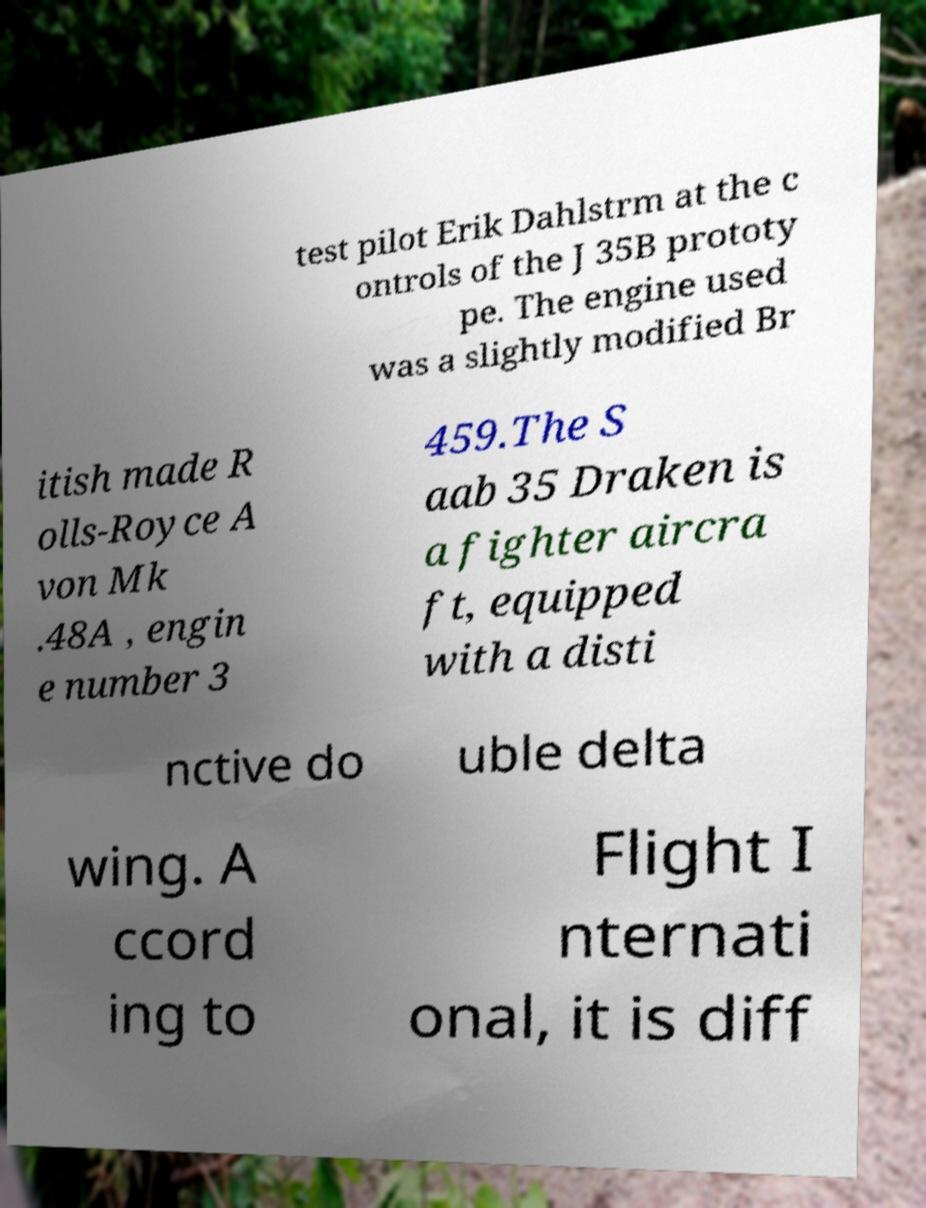There's text embedded in this image that I need extracted. Can you transcribe it verbatim? test pilot Erik Dahlstrm at the c ontrols of the J 35B prototy pe. The engine used was a slightly modified Br itish made R olls-Royce A von Mk .48A , engin e number 3 459.The S aab 35 Draken is a fighter aircra ft, equipped with a disti nctive do uble delta wing. A ccord ing to Flight I nternati onal, it is diff 